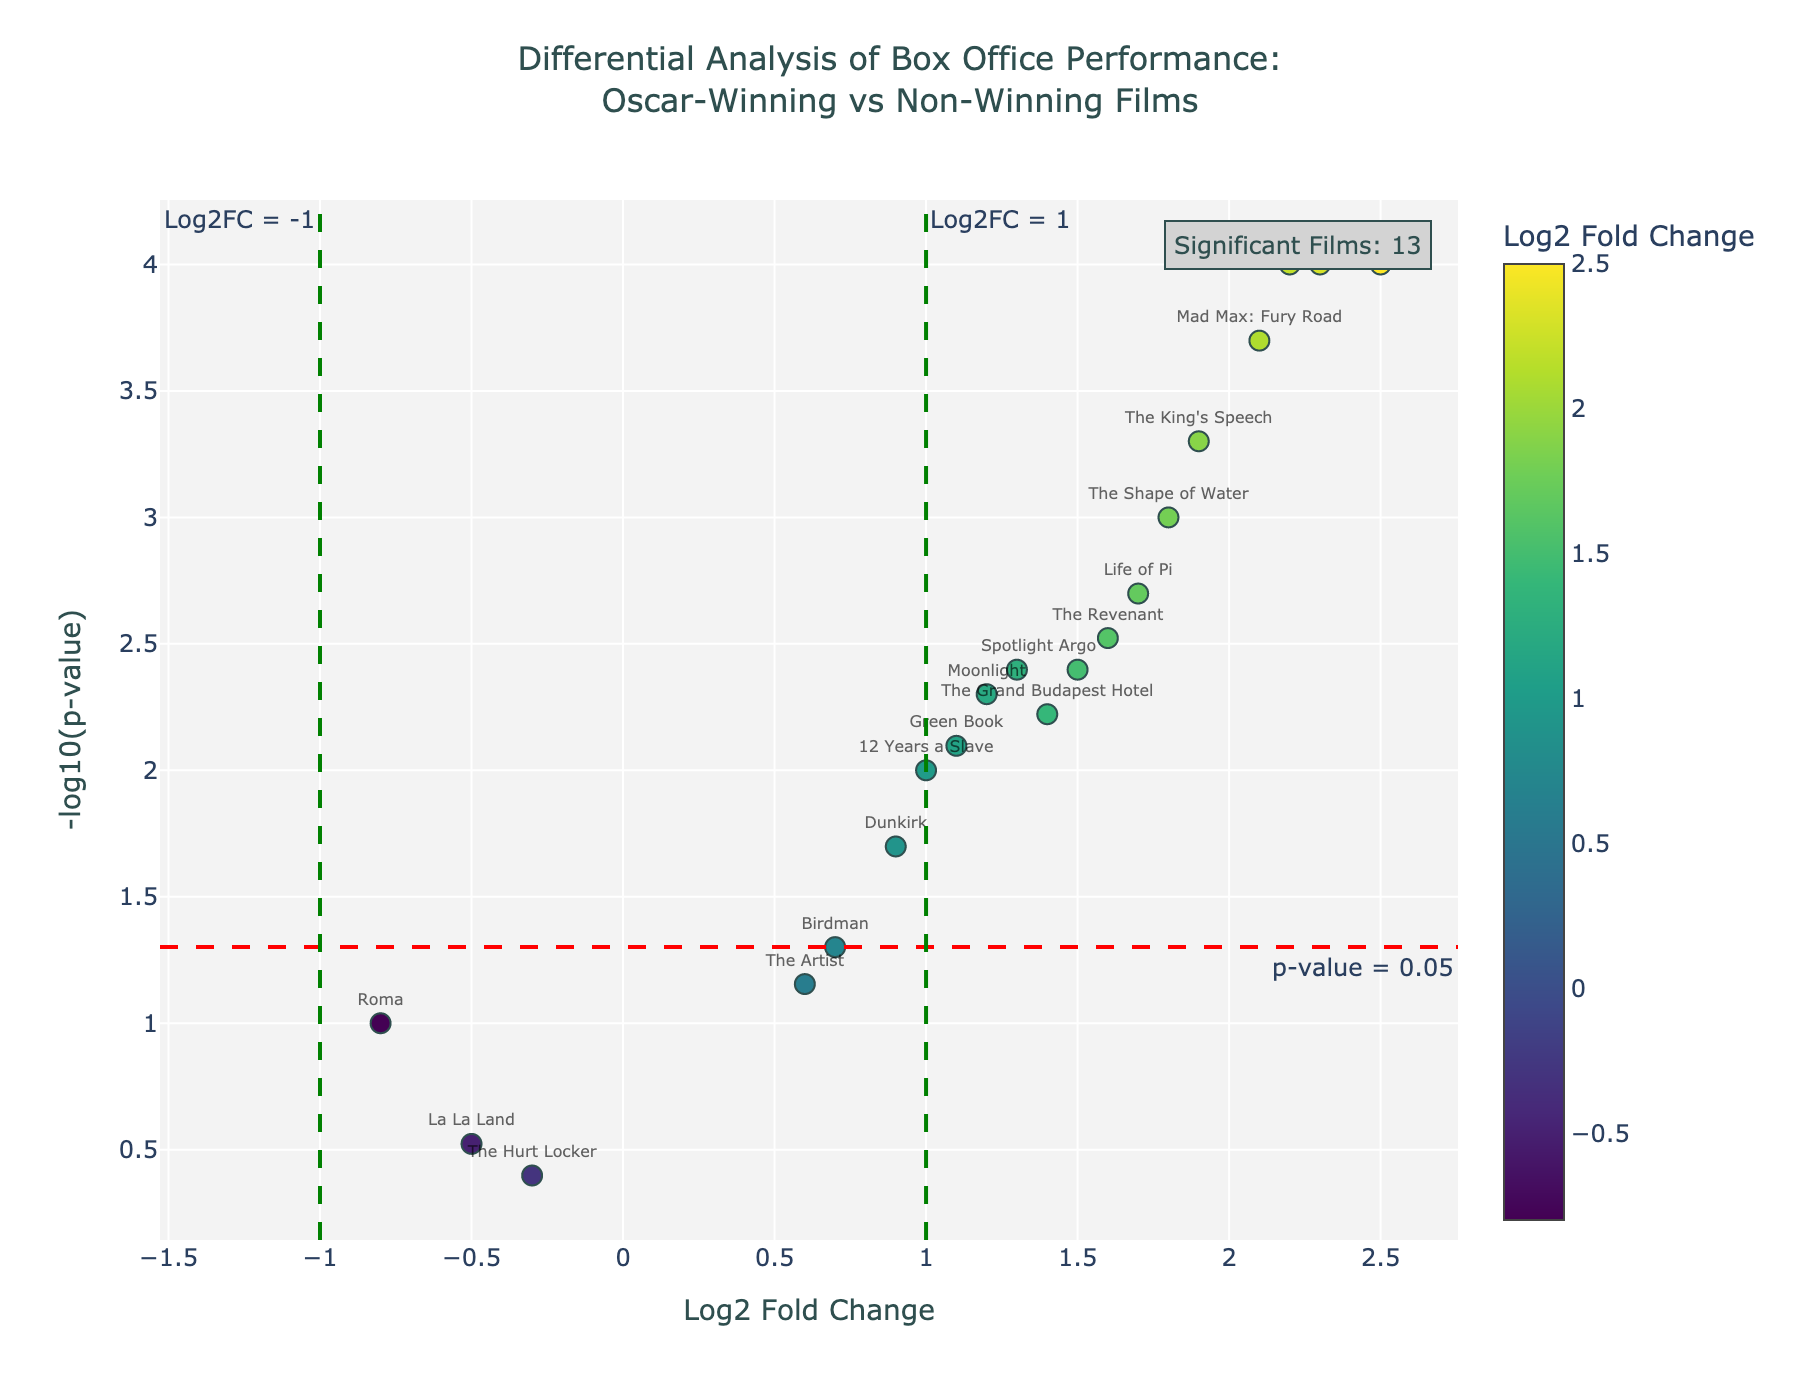What is the title of the volcano plot? The title of the plot is located at the top of the figure, which provides a brief description of what the plot represents. The title here is "Differential Analysis of Box Office Performance: Oscar-Winning vs Non-Winning Films".
Answer: Differential Analysis of Box Office Performance: Oscar-Winning vs Non-Winning Films What do the colors of the data points represent? The colors of the data points correspond to the Log2 Fold Change values. The color gradient indicates the degree of fold change based on the Viridis color scale, where different shades represent different fold changes.
Answer: Log2 Fold Change values How many films are considered significant in the analysis? Significant films are those that meet the threshold for Log2 Fold Change (greater than 1 or less than -1) and have a p-value less than 0.05. According to the annotation in the top right of the plot, there are 12 significant films.
Answer: 12 Which film has the highest Log2 Fold Change and what is its p-value? Locate the data point with the highest Log2 Fold Change on the x-axis. "Parasite" is the film with the highest Log2 Fold Change at 2.5, and its corresponding p-value is 0.0001.
Answer: Parasite, 0.0001 Which film is the least significant in the plot? The least significant film can be identified by having the lowest y-value, indicative of the highest p-value. "The Hurt Locker" is the least significant film with a PValue of 0.4.
Answer: The Hurt Locker How many films have a Log2 Fold Change less than 0? To answer this, count the number of data points with an x-value (Log2 Fold Change) less than 0. "La La Land", "Roma", and "The Hurt Locker" have values less than 0.
Answer: 3 What is the Log2 Fold Change value and p-value for "The King's Speech"? By checking the hover text corresponding to "The King's Speech" on the plot, we find that it has a Log2 Fold Change of 1.9 and a PValue of 0.0005.
Answer: 1.9, 0.0005 Which films have a Log2 Fold Change greater than 2 and what are their p-values? Identify the data points with Log2 Fold Change greater than 2 on the x-axis. The films meeting this criterion are "Parasite", "Gravity", and "Inception" with p-values of 0.0001 each.
Answer: 3 (Parasite, Gravity, Inception) Compare the significant results for "The Revenant" and "Green Book"; which one has a lower p-value? Both films are significant as they meet the threshold criteria. By checking their p-values, "The Revenant" has a p-value of 0.003 while "Green Book" has a p-value of 0.008. Therefore, "The Revenant" has a lower p-value.
Answer: The Revenant What is the implication if a film has a Log2 Fold Change of 1 and a corresponding PValue less than 0.05 in this analysis? A Log2 Fold Change of 1 implies that the box office performance has doubled. If the PValue is less than 0.05, it indicates that the result is statistically significant. Therefore, the film significantly outperformed by two-fold in box office performance.
Answer: Doubled performance and statistically significant 